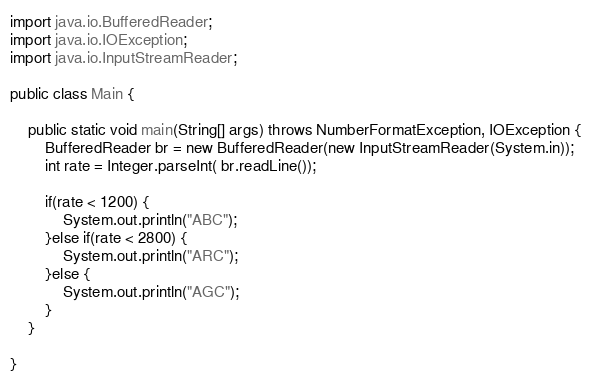Convert code to text. <code><loc_0><loc_0><loc_500><loc_500><_Java_>
import java.io.BufferedReader;
import java.io.IOException;
import java.io.InputStreamReader;

public class Main {

	public static void main(String[] args) throws NumberFormatException, IOException {
		BufferedReader br = new BufferedReader(new InputStreamReader(System.in));
		int rate = Integer.parseInt( br.readLine());

		if(rate < 1200) {
			System.out.println("ABC");
		}else if(rate < 2800) {
			System.out.println("ARC");
		}else {
			System.out.println("AGC");
		}
	}

}
</code> 